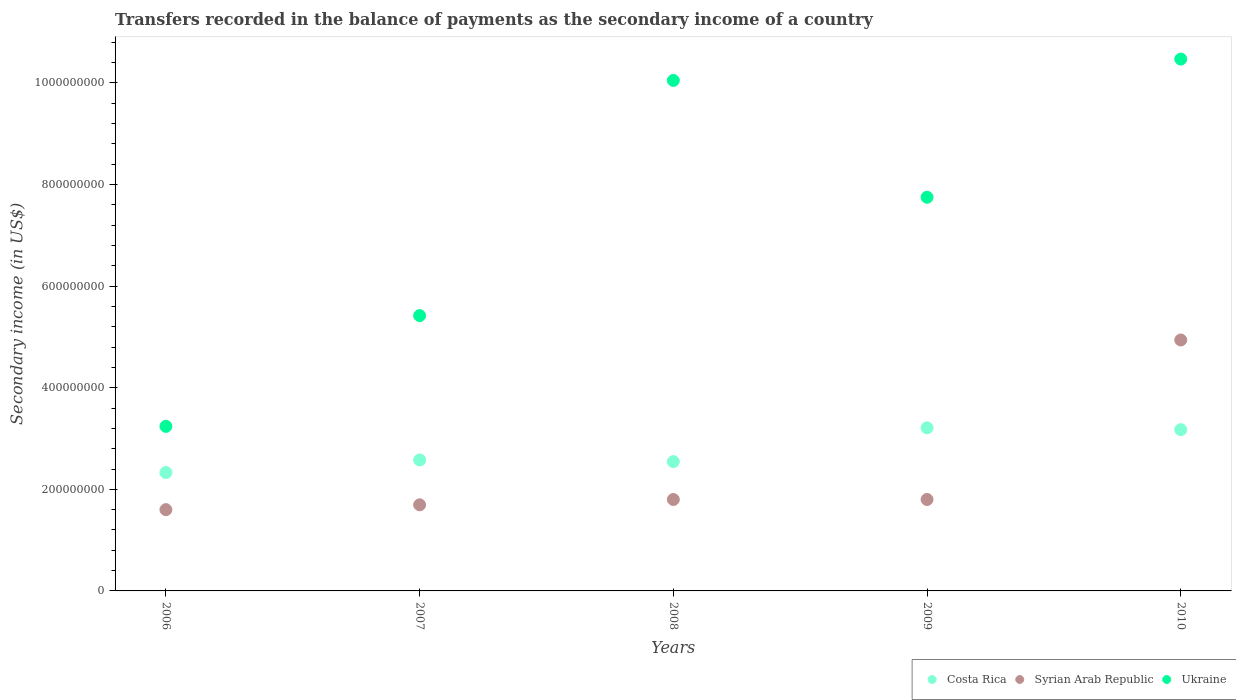How many different coloured dotlines are there?
Your response must be concise. 3. Is the number of dotlines equal to the number of legend labels?
Give a very brief answer. Yes. What is the secondary income of in Syrian Arab Republic in 2008?
Make the answer very short. 1.80e+08. Across all years, what is the maximum secondary income of in Syrian Arab Republic?
Give a very brief answer. 4.94e+08. Across all years, what is the minimum secondary income of in Costa Rica?
Provide a short and direct response. 2.33e+08. In which year was the secondary income of in Costa Rica maximum?
Provide a short and direct response. 2009. In which year was the secondary income of in Syrian Arab Republic minimum?
Your response must be concise. 2006. What is the total secondary income of in Syrian Arab Republic in the graph?
Your answer should be compact. 1.18e+09. What is the difference between the secondary income of in Syrian Arab Republic in 2007 and that in 2010?
Your answer should be compact. -3.24e+08. What is the difference between the secondary income of in Costa Rica in 2006 and the secondary income of in Ukraine in 2007?
Offer a terse response. -3.09e+08. What is the average secondary income of in Syrian Arab Republic per year?
Ensure brevity in your answer.  2.37e+08. In the year 2006, what is the difference between the secondary income of in Ukraine and secondary income of in Syrian Arab Republic?
Your answer should be compact. 1.64e+08. What is the ratio of the secondary income of in Ukraine in 2009 to that in 2010?
Keep it short and to the point. 0.74. What is the difference between the highest and the second highest secondary income of in Ukraine?
Make the answer very short. 4.20e+07. What is the difference between the highest and the lowest secondary income of in Ukraine?
Provide a short and direct response. 7.23e+08. Is the sum of the secondary income of in Ukraine in 2007 and 2008 greater than the maximum secondary income of in Syrian Arab Republic across all years?
Make the answer very short. Yes. Is the secondary income of in Costa Rica strictly less than the secondary income of in Syrian Arab Republic over the years?
Your answer should be compact. No. How many dotlines are there?
Make the answer very short. 3. How many years are there in the graph?
Provide a succinct answer. 5. Are the values on the major ticks of Y-axis written in scientific E-notation?
Give a very brief answer. No. Does the graph contain grids?
Provide a short and direct response. No. Where does the legend appear in the graph?
Make the answer very short. Bottom right. How are the legend labels stacked?
Provide a short and direct response. Horizontal. What is the title of the graph?
Provide a short and direct response. Transfers recorded in the balance of payments as the secondary income of a country. Does "Sweden" appear as one of the legend labels in the graph?
Keep it short and to the point. No. What is the label or title of the Y-axis?
Make the answer very short. Secondary income (in US$). What is the Secondary income (in US$) of Costa Rica in 2006?
Your answer should be very brief. 2.33e+08. What is the Secondary income (in US$) in Syrian Arab Republic in 2006?
Your answer should be very brief. 1.60e+08. What is the Secondary income (in US$) of Ukraine in 2006?
Make the answer very short. 3.24e+08. What is the Secondary income (in US$) in Costa Rica in 2007?
Provide a succinct answer. 2.58e+08. What is the Secondary income (in US$) of Syrian Arab Republic in 2007?
Provide a short and direct response. 1.70e+08. What is the Secondary income (in US$) of Ukraine in 2007?
Provide a short and direct response. 5.42e+08. What is the Secondary income (in US$) in Costa Rica in 2008?
Offer a terse response. 2.55e+08. What is the Secondary income (in US$) in Syrian Arab Republic in 2008?
Give a very brief answer. 1.80e+08. What is the Secondary income (in US$) of Ukraine in 2008?
Give a very brief answer. 1.00e+09. What is the Secondary income (in US$) of Costa Rica in 2009?
Provide a succinct answer. 3.21e+08. What is the Secondary income (in US$) in Syrian Arab Republic in 2009?
Your response must be concise. 1.80e+08. What is the Secondary income (in US$) in Ukraine in 2009?
Your answer should be very brief. 7.75e+08. What is the Secondary income (in US$) in Costa Rica in 2010?
Your answer should be very brief. 3.17e+08. What is the Secondary income (in US$) of Syrian Arab Republic in 2010?
Offer a terse response. 4.94e+08. What is the Secondary income (in US$) of Ukraine in 2010?
Your response must be concise. 1.05e+09. Across all years, what is the maximum Secondary income (in US$) in Costa Rica?
Offer a very short reply. 3.21e+08. Across all years, what is the maximum Secondary income (in US$) in Syrian Arab Republic?
Keep it short and to the point. 4.94e+08. Across all years, what is the maximum Secondary income (in US$) in Ukraine?
Provide a short and direct response. 1.05e+09. Across all years, what is the minimum Secondary income (in US$) of Costa Rica?
Your answer should be very brief. 2.33e+08. Across all years, what is the minimum Secondary income (in US$) in Syrian Arab Republic?
Your answer should be compact. 1.60e+08. Across all years, what is the minimum Secondary income (in US$) of Ukraine?
Offer a terse response. 3.24e+08. What is the total Secondary income (in US$) of Costa Rica in the graph?
Your answer should be compact. 1.38e+09. What is the total Secondary income (in US$) of Syrian Arab Republic in the graph?
Provide a succinct answer. 1.18e+09. What is the total Secondary income (in US$) of Ukraine in the graph?
Provide a succinct answer. 3.69e+09. What is the difference between the Secondary income (in US$) in Costa Rica in 2006 and that in 2007?
Provide a short and direct response. -2.47e+07. What is the difference between the Secondary income (in US$) of Syrian Arab Republic in 2006 and that in 2007?
Make the answer very short. -9.50e+06. What is the difference between the Secondary income (in US$) of Ukraine in 2006 and that in 2007?
Ensure brevity in your answer.  -2.18e+08. What is the difference between the Secondary income (in US$) of Costa Rica in 2006 and that in 2008?
Your response must be concise. -2.15e+07. What is the difference between the Secondary income (in US$) in Syrian Arab Republic in 2006 and that in 2008?
Make the answer very short. -2.00e+07. What is the difference between the Secondary income (in US$) in Ukraine in 2006 and that in 2008?
Offer a very short reply. -6.81e+08. What is the difference between the Secondary income (in US$) of Costa Rica in 2006 and that in 2009?
Ensure brevity in your answer.  -8.80e+07. What is the difference between the Secondary income (in US$) of Syrian Arab Republic in 2006 and that in 2009?
Offer a very short reply. -2.00e+07. What is the difference between the Secondary income (in US$) in Ukraine in 2006 and that in 2009?
Provide a succinct answer. -4.51e+08. What is the difference between the Secondary income (in US$) of Costa Rica in 2006 and that in 2010?
Give a very brief answer. -8.44e+07. What is the difference between the Secondary income (in US$) of Syrian Arab Republic in 2006 and that in 2010?
Your answer should be very brief. -3.34e+08. What is the difference between the Secondary income (in US$) in Ukraine in 2006 and that in 2010?
Your answer should be compact. -7.23e+08. What is the difference between the Secondary income (in US$) of Costa Rica in 2007 and that in 2008?
Make the answer very short. 3.20e+06. What is the difference between the Secondary income (in US$) in Syrian Arab Republic in 2007 and that in 2008?
Give a very brief answer. -1.05e+07. What is the difference between the Secondary income (in US$) in Ukraine in 2007 and that in 2008?
Give a very brief answer. -4.63e+08. What is the difference between the Secondary income (in US$) of Costa Rica in 2007 and that in 2009?
Offer a terse response. -6.33e+07. What is the difference between the Secondary income (in US$) of Syrian Arab Republic in 2007 and that in 2009?
Ensure brevity in your answer.  -1.05e+07. What is the difference between the Secondary income (in US$) of Ukraine in 2007 and that in 2009?
Your answer should be very brief. -2.33e+08. What is the difference between the Secondary income (in US$) in Costa Rica in 2007 and that in 2010?
Your answer should be very brief. -5.97e+07. What is the difference between the Secondary income (in US$) of Syrian Arab Republic in 2007 and that in 2010?
Ensure brevity in your answer.  -3.24e+08. What is the difference between the Secondary income (in US$) in Ukraine in 2007 and that in 2010?
Give a very brief answer. -5.05e+08. What is the difference between the Secondary income (in US$) in Costa Rica in 2008 and that in 2009?
Make the answer very short. -6.65e+07. What is the difference between the Secondary income (in US$) in Ukraine in 2008 and that in 2009?
Ensure brevity in your answer.  2.30e+08. What is the difference between the Secondary income (in US$) in Costa Rica in 2008 and that in 2010?
Give a very brief answer. -6.29e+07. What is the difference between the Secondary income (in US$) in Syrian Arab Republic in 2008 and that in 2010?
Your answer should be very brief. -3.14e+08. What is the difference between the Secondary income (in US$) in Ukraine in 2008 and that in 2010?
Give a very brief answer. -4.20e+07. What is the difference between the Secondary income (in US$) in Costa Rica in 2009 and that in 2010?
Make the answer very short. 3.59e+06. What is the difference between the Secondary income (in US$) in Syrian Arab Republic in 2009 and that in 2010?
Your answer should be very brief. -3.14e+08. What is the difference between the Secondary income (in US$) of Ukraine in 2009 and that in 2010?
Offer a very short reply. -2.72e+08. What is the difference between the Secondary income (in US$) in Costa Rica in 2006 and the Secondary income (in US$) in Syrian Arab Republic in 2007?
Offer a very short reply. 6.36e+07. What is the difference between the Secondary income (in US$) of Costa Rica in 2006 and the Secondary income (in US$) of Ukraine in 2007?
Offer a terse response. -3.09e+08. What is the difference between the Secondary income (in US$) of Syrian Arab Republic in 2006 and the Secondary income (in US$) of Ukraine in 2007?
Keep it short and to the point. -3.82e+08. What is the difference between the Secondary income (in US$) of Costa Rica in 2006 and the Secondary income (in US$) of Syrian Arab Republic in 2008?
Make the answer very short. 5.31e+07. What is the difference between the Secondary income (in US$) of Costa Rica in 2006 and the Secondary income (in US$) of Ukraine in 2008?
Give a very brief answer. -7.72e+08. What is the difference between the Secondary income (in US$) in Syrian Arab Republic in 2006 and the Secondary income (in US$) in Ukraine in 2008?
Offer a very short reply. -8.45e+08. What is the difference between the Secondary income (in US$) of Costa Rica in 2006 and the Secondary income (in US$) of Syrian Arab Republic in 2009?
Your response must be concise. 5.31e+07. What is the difference between the Secondary income (in US$) of Costa Rica in 2006 and the Secondary income (in US$) of Ukraine in 2009?
Make the answer very short. -5.42e+08. What is the difference between the Secondary income (in US$) in Syrian Arab Republic in 2006 and the Secondary income (in US$) in Ukraine in 2009?
Offer a terse response. -6.15e+08. What is the difference between the Secondary income (in US$) of Costa Rica in 2006 and the Secondary income (in US$) of Syrian Arab Republic in 2010?
Your response must be concise. -2.61e+08. What is the difference between the Secondary income (in US$) in Costa Rica in 2006 and the Secondary income (in US$) in Ukraine in 2010?
Provide a short and direct response. -8.14e+08. What is the difference between the Secondary income (in US$) in Syrian Arab Republic in 2006 and the Secondary income (in US$) in Ukraine in 2010?
Ensure brevity in your answer.  -8.87e+08. What is the difference between the Secondary income (in US$) of Costa Rica in 2007 and the Secondary income (in US$) of Syrian Arab Republic in 2008?
Give a very brief answer. 7.78e+07. What is the difference between the Secondary income (in US$) of Costa Rica in 2007 and the Secondary income (in US$) of Ukraine in 2008?
Your answer should be very brief. -7.47e+08. What is the difference between the Secondary income (in US$) in Syrian Arab Republic in 2007 and the Secondary income (in US$) in Ukraine in 2008?
Make the answer very short. -8.36e+08. What is the difference between the Secondary income (in US$) in Costa Rica in 2007 and the Secondary income (in US$) in Syrian Arab Republic in 2009?
Keep it short and to the point. 7.78e+07. What is the difference between the Secondary income (in US$) of Costa Rica in 2007 and the Secondary income (in US$) of Ukraine in 2009?
Your answer should be very brief. -5.17e+08. What is the difference between the Secondary income (in US$) of Syrian Arab Republic in 2007 and the Secondary income (in US$) of Ukraine in 2009?
Make the answer very short. -6.06e+08. What is the difference between the Secondary income (in US$) of Costa Rica in 2007 and the Secondary income (in US$) of Syrian Arab Republic in 2010?
Ensure brevity in your answer.  -2.36e+08. What is the difference between the Secondary income (in US$) of Costa Rica in 2007 and the Secondary income (in US$) of Ukraine in 2010?
Give a very brief answer. -7.89e+08. What is the difference between the Secondary income (in US$) in Syrian Arab Republic in 2007 and the Secondary income (in US$) in Ukraine in 2010?
Provide a short and direct response. -8.78e+08. What is the difference between the Secondary income (in US$) in Costa Rica in 2008 and the Secondary income (in US$) in Syrian Arab Republic in 2009?
Provide a short and direct response. 7.46e+07. What is the difference between the Secondary income (in US$) of Costa Rica in 2008 and the Secondary income (in US$) of Ukraine in 2009?
Keep it short and to the point. -5.20e+08. What is the difference between the Secondary income (in US$) in Syrian Arab Republic in 2008 and the Secondary income (in US$) in Ukraine in 2009?
Give a very brief answer. -5.95e+08. What is the difference between the Secondary income (in US$) in Costa Rica in 2008 and the Secondary income (in US$) in Syrian Arab Republic in 2010?
Ensure brevity in your answer.  -2.39e+08. What is the difference between the Secondary income (in US$) in Costa Rica in 2008 and the Secondary income (in US$) in Ukraine in 2010?
Give a very brief answer. -7.92e+08. What is the difference between the Secondary income (in US$) of Syrian Arab Republic in 2008 and the Secondary income (in US$) of Ukraine in 2010?
Ensure brevity in your answer.  -8.67e+08. What is the difference between the Secondary income (in US$) of Costa Rica in 2009 and the Secondary income (in US$) of Syrian Arab Republic in 2010?
Offer a very short reply. -1.73e+08. What is the difference between the Secondary income (in US$) of Costa Rica in 2009 and the Secondary income (in US$) of Ukraine in 2010?
Make the answer very short. -7.26e+08. What is the difference between the Secondary income (in US$) in Syrian Arab Republic in 2009 and the Secondary income (in US$) in Ukraine in 2010?
Offer a terse response. -8.67e+08. What is the average Secondary income (in US$) of Costa Rica per year?
Keep it short and to the point. 2.77e+08. What is the average Secondary income (in US$) in Syrian Arab Republic per year?
Provide a short and direct response. 2.37e+08. What is the average Secondary income (in US$) of Ukraine per year?
Ensure brevity in your answer.  7.39e+08. In the year 2006, what is the difference between the Secondary income (in US$) of Costa Rica and Secondary income (in US$) of Syrian Arab Republic?
Give a very brief answer. 7.31e+07. In the year 2006, what is the difference between the Secondary income (in US$) in Costa Rica and Secondary income (in US$) in Ukraine?
Offer a terse response. -9.09e+07. In the year 2006, what is the difference between the Secondary income (in US$) of Syrian Arab Republic and Secondary income (in US$) of Ukraine?
Your response must be concise. -1.64e+08. In the year 2007, what is the difference between the Secondary income (in US$) of Costa Rica and Secondary income (in US$) of Syrian Arab Republic?
Your answer should be very brief. 8.83e+07. In the year 2007, what is the difference between the Secondary income (in US$) of Costa Rica and Secondary income (in US$) of Ukraine?
Give a very brief answer. -2.84e+08. In the year 2007, what is the difference between the Secondary income (in US$) in Syrian Arab Republic and Secondary income (in US$) in Ukraine?
Your answer should be compact. -3.72e+08. In the year 2008, what is the difference between the Secondary income (in US$) in Costa Rica and Secondary income (in US$) in Syrian Arab Republic?
Your answer should be compact. 7.46e+07. In the year 2008, what is the difference between the Secondary income (in US$) in Costa Rica and Secondary income (in US$) in Ukraine?
Offer a terse response. -7.50e+08. In the year 2008, what is the difference between the Secondary income (in US$) of Syrian Arab Republic and Secondary income (in US$) of Ukraine?
Offer a very short reply. -8.25e+08. In the year 2009, what is the difference between the Secondary income (in US$) of Costa Rica and Secondary income (in US$) of Syrian Arab Republic?
Keep it short and to the point. 1.41e+08. In the year 2009, what is the difference between the Secondary income (in US$) of Costa Rica and Secondary income (in US$) of Ukraine?
Keep it short and to the point. -4.54e+08. In the year 2009, what is the difference between the Secondary income (in US$) in Syrian Arab Republic and Secondary income (in US$) in Ukraine?
Offer a terse response. -5.95e+08. In the year 2010, what is the difference between the Secondary income (in US$) of Costa Rica and Secondary income (in US$) of Syrian Arab Republic?
Offer a very short reply. -1.77e+08. In the year 2010, what is the difference between the Secondary income (in US$) of Costa Rica and Secondary income (in US$) of Ukraine?
Your answer should be very brief. -7.30e+08. In the year 2010, what is the difference between the Secondary income (in US$) in Syrian Arab Republic and Secondary income (in US$) in Ukraine?
Ensure brevity in your answer.  -5.53e+08. What is the ratio of the Secondary income (in US$) of Costa Rica in 2006 to that in 2007?
Your response must be concise. 0.9. What is the ratio of the Secondary income (in US$) in Syrian Arab Republic in 2006 to that in 2007?
Offer a terse response. 0.94. What is the ratio of the Secondary income (in US$) in Ukraine in 2006 to that in 2007?
Your answer should be compact. 0.6. What is the ratio of the Secondary income (in US$) of Costa Rica in 2006 to that in 2008?
Your response must be concise. 0.92. What is the ratio of the Secondary income (in US$) of Ukraine in 2006 to that in 2008?
Make the answer very short. 0.32. What is the ratio of the Secondary income (in US$) of Costa Rica in 2006 to that in 2009?
Give a very brief answer. 0.73. What is the ratio of the Secondary income (in US$) of Ukraine in 2006 to that in 2009?
Ensure brevity in your answer.  0.42. What is the ratio of the Secondary income (in US$) of Costa Rica in 2006 to that in 2010?
Your answer should be very brief. 0.73. What is the ratio of the Secondary income (in US$) in Syrian Arab Republic in 2006 to that in 2010?
Provide a succinct answer. 0.32. What is the ratio of the Secondary income (in US$) of Ukraine in 2006 to that in 2010?
Your response must be concise. 0.31. What is the ratio of the Secondary income (in US$) of Costa Rica in 2007 to that in 2008?
Give a very brief answer. 1.01. What is the ratio of the Secondary income (in US$) in Syrian Arab Republic in 2007 to that in 2008?
Your response must be concise. 0.94. What is the ratio of the Secondary income (in US$) of Ukraine in 2007 to that in 2008?
Ensure brevity in your answer.  0.54. What is the ratio of the Secondary income (in US$) in Costa Rica in 2007 to that in 2009?
Provide a succinct answer. 0.8. What is the ratio of the Secondary income (in US$) of Syrian Arab Republic in 2007 to that in 2009?
Keep it short and to the point. 0.94. What is the ratio of the Secondary income (in US$) in Ukraine in 2007 to that in 2009?
Provide a succinct answer. 0.7. What is the ratio of the Secondary income (in US$) of Costa Rica in 2007 to that in 2010?
Offer a terse response. 0.81. What is the ratio of the Secondary income (in US$) of Syrian Arab Republic in 2007 to that in 2010?
Give a very brief answer. 0.34. What is the ratio of the Secondary income (in US$) of Ukraine in 2007 to that in 2010?
Your response must be concise. 0.52. What is the ratio of the Secondary income (in US$) of Costa Rica in 2008 to that in 2009?
Provide a short and direct response. 0.79. What is the ratio of the Secondary income (in US$) of Syrian Arab Republic in 2008 to that in 2009?
Provide a succinct answer. 1. What is the ratio of the Secondary income (in US$) in Ukraine in 2008 to that in 2009?
Offer a very short reply. 1.3. What is the ratio of the Secondary income (in US$) in Costa Rica in 2008 to that in 2010?
Your response must be concise. 0.8. What is the ratio of the Secondary income (in US$) of Syrian Arab Republic in 2008 to that in 2010?
Ensure brevity in your answer.  0.36. What is the ratio of the Secondary income (in US$) in Ukraine in 2008 to that in 2010?
Your answer should be compact. 0.96. What is the ratio of the Secondary income (in US$) of Costa Rica in 2009 to that in 2010?
Provide a succinct answer. 1.01. What is the ratio of the Secondary income (in US$) of Syrian Arab Republic in 2009 to that in 2010?
Make the answer very short. 0.36. What is the ratio of the Secondary income (in US$) in Ukraine in 2009 to that in 2010?
Make the answer very short. 0.74. What is the difference between the highest and the second highest Secondary income (in US$) of Costa Rica?
Your response must be concise. 3.59e+06. What is the difference between the highest and the second highest Secondary income (in US$) in Syrian Arab Republic?
Your answer should be very brief. 3.14e+08. What is the difference between the highest and the second highest Secondary income (in US$) in Ukraine?
Ensure brevity in your answer.  4.20e+07. What is the difference between the highest and the lowest Secondary income (in US$) of Costa Rica?
Ensure brevity in your answer.  8.80e+07. What is the difference between the highest and the lowest Secondary income (in US$) in Syrian Arab Republic?
Make the answer very short. 3.34e+08. What is the difference between the highest and the lowest Secondary income (in US$) in Ukraine?
Offer a very short reply. 7.23e+08. 